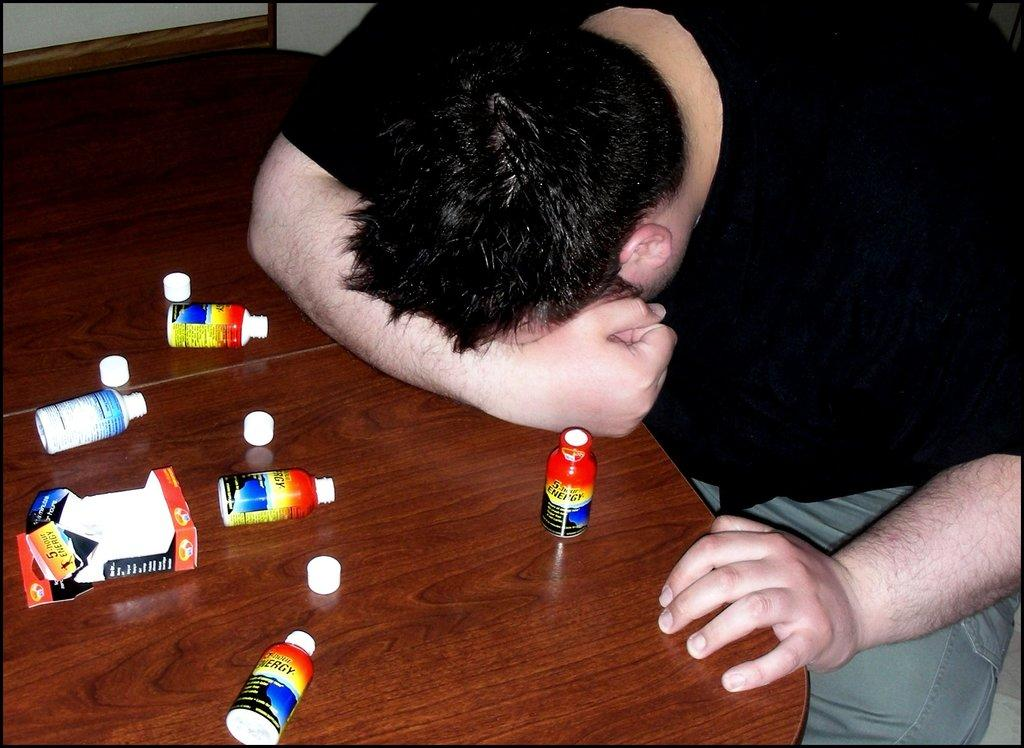What is the person in the image doing? The person is sleeping in the image. Where is the person sleeping? The person is sleeping at a table. What can be seen in the background of the image? There is a wall in the background of the image. What objects are on the table with the sleeping person? There are bottles on the table in the image. What type of veil is covering the person's face in the image? There is no veil present in the image; the person is simply sleeping at a table. 